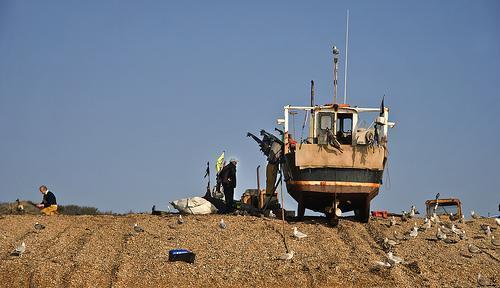How many people are in the picture?
Give a very brief answer. 2. How many heavy equipment vehicles are behind the boat?
Give a very brief answer. 2. How many clouds are in the sky?
Give a very brief answer. 0. 